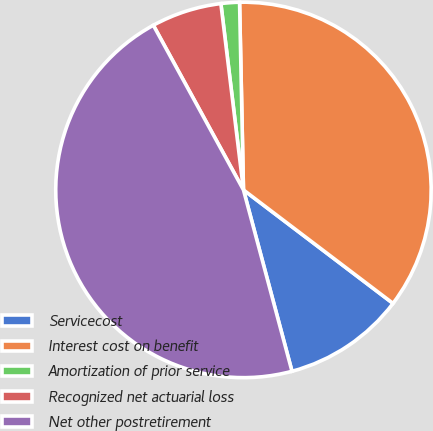Convert chart. <chart><loc_0><loc_0><loc_500><loc_500><pie_chart><fcel>Servicecost<fcel>Interest cost on benefit<fcel>Amortization of prior service<fcel>Recognized net actuarial loss<fcel>Net other postretirement<nl><fcel>10.51%<fcel>35.66%<fcel>1.59%<fcel>6.05%<fcel>46.19%<nl></chart> 